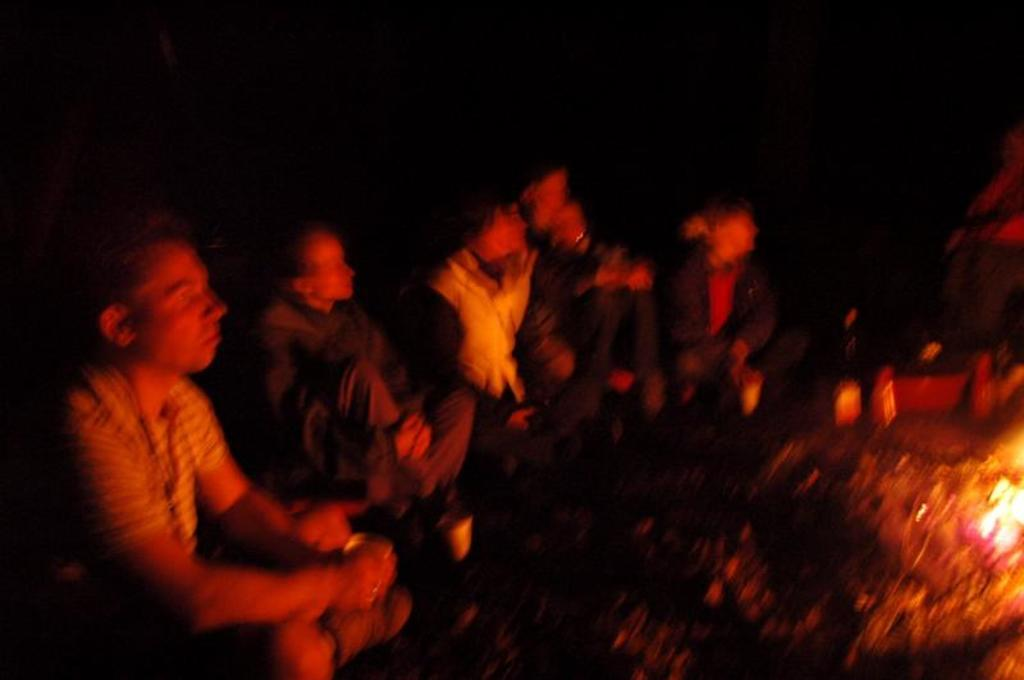How many people are in the image? There is a group of persons in the image, but the exact number is not specified. What are the persons in the image doing? The persons are sitting on the ground. What is in front of the group? There is a fire in front of the group. What can be observed about the background of the image? The background of the image is dark in color. What type of net is being used to catch fish in the image? There is no net or fishing activity present in the image. How does the oven contribute to the group's behavior in the image? There is no oven or any indication of cooking in the image. 